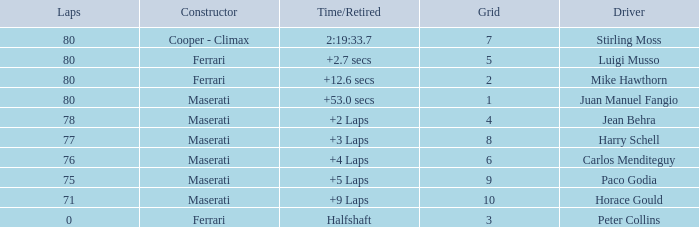What's the average Grid for a Maserati with less than 80 laps, and a Time/Retired of +2 laps? 4.0. 